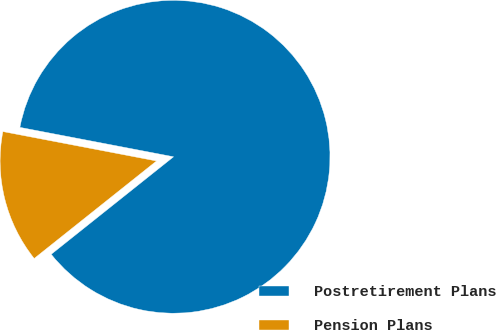Convert chart. <chart><loc_0><loc_0><loc_500><loc_500><pie_chart><fcel>Postretirement Plans<fcel>Pension Plans<nl><fcel>86.28%<fcel>13.72%<nl></chart> 